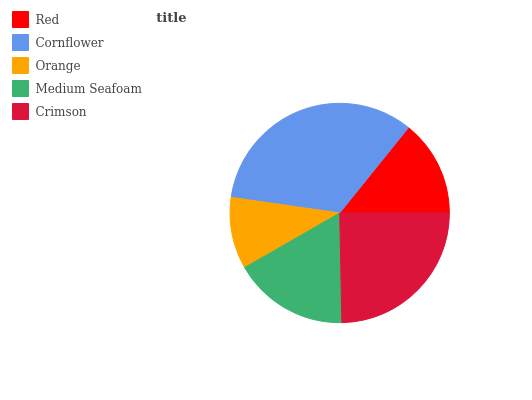Is Orange the minimum?
Answer yes or no. Yes. Is Cornflower the maximum?
Answer yes or no. Yes. Is Cornflower the minimum?
Answer yes or no. No. Is Orange the maximum?
Answer yes or no. No. Is Cornflower greater than Orange?
Answer yes or no. Yes. Is Orange less than Cornflower?
Answer yes or no. Yes. Is Orange greater than Cornflower?
Answer yes or no. No. Is Cornflower less than Orange?
Answer yes or no. No. Is Medium Seafoam the high median?
Answer yes or no. Yes. Is Medium Seafoam the low median?
Answer yes or no. Yes. Is Orange the high median?
Answer yes or no. No. Is Orange the low median?
Answer yes or no. No. 